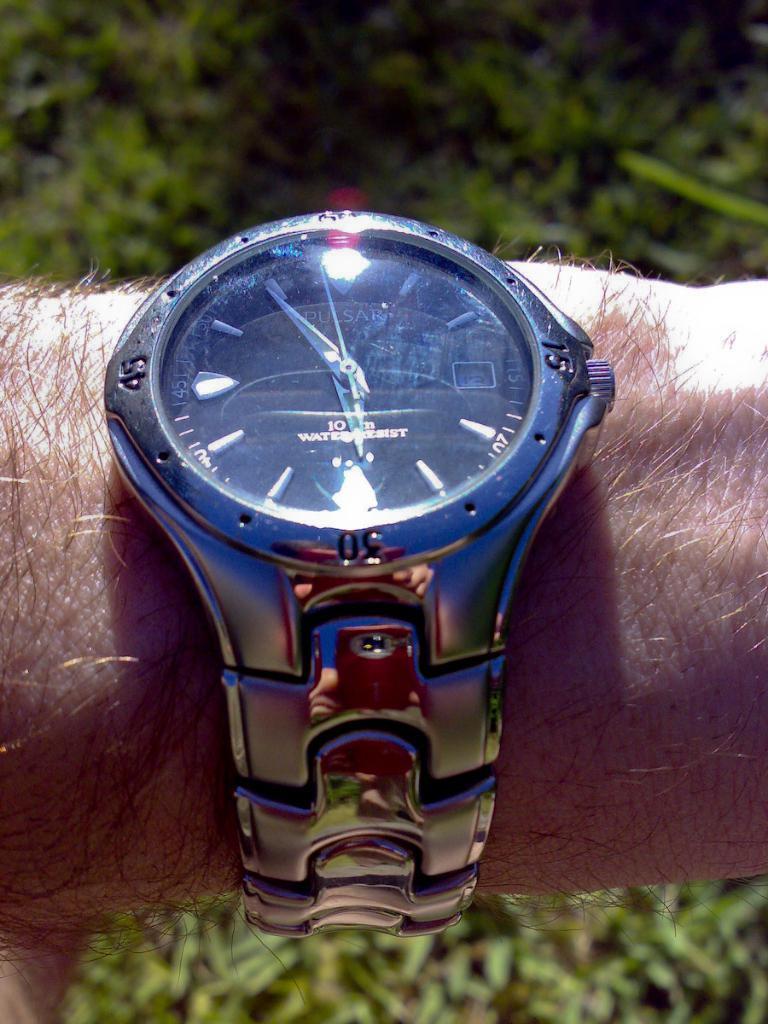What time is it?
Keep it short and to the point. 5:55. What number is on the left of the watch?
Give a very brief answer. 45. 